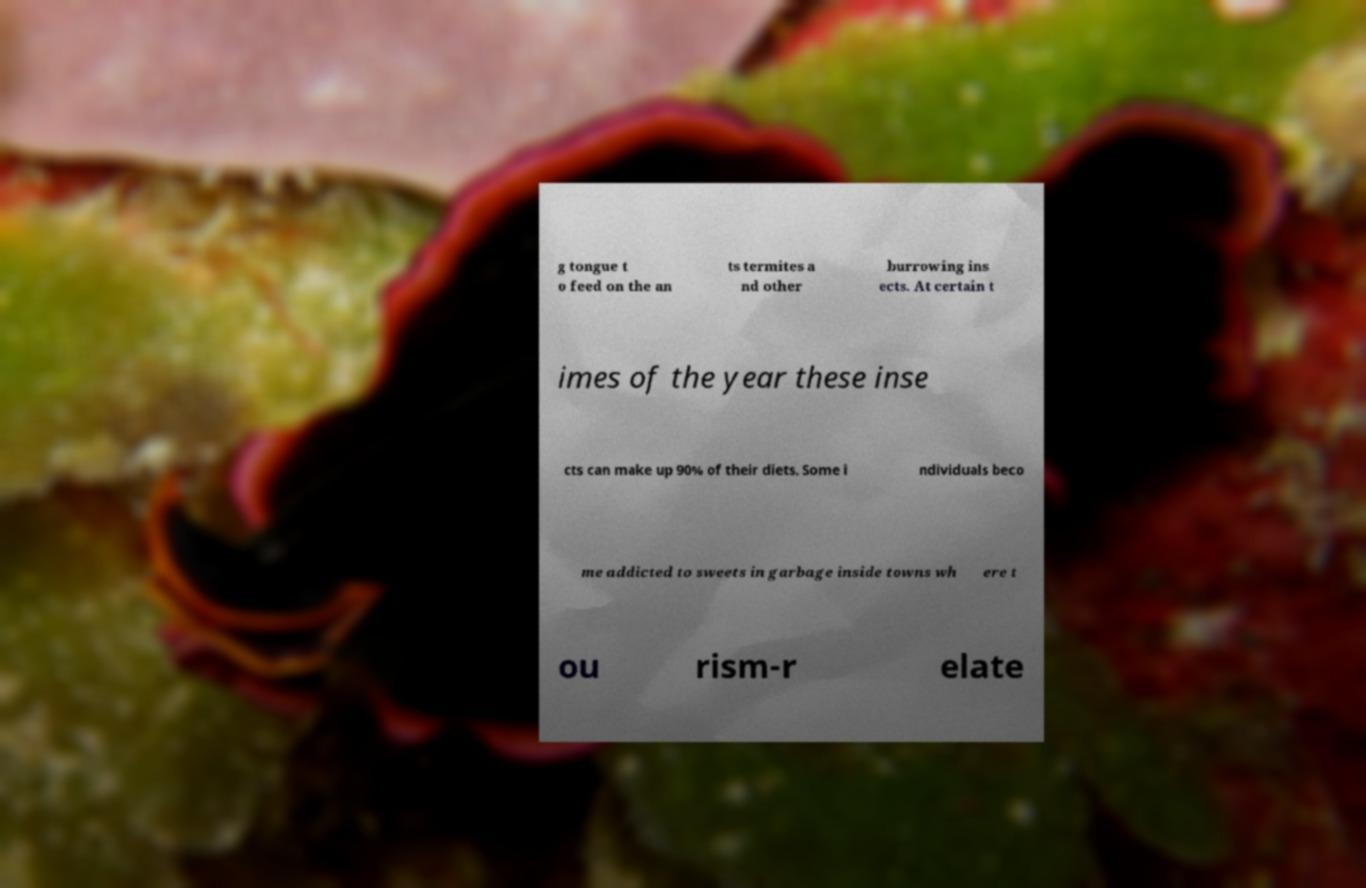Please read and relay the text visible in this image. What does it say? g tongue t o feed on the an ts termites a nd other burrowing ins ects. At certain t imes of the year these inse cts can make up 90% of their diets. Some i ndividuals beco me addicted to sweets in garbage inside towns wh ere t ou rism-r elate 